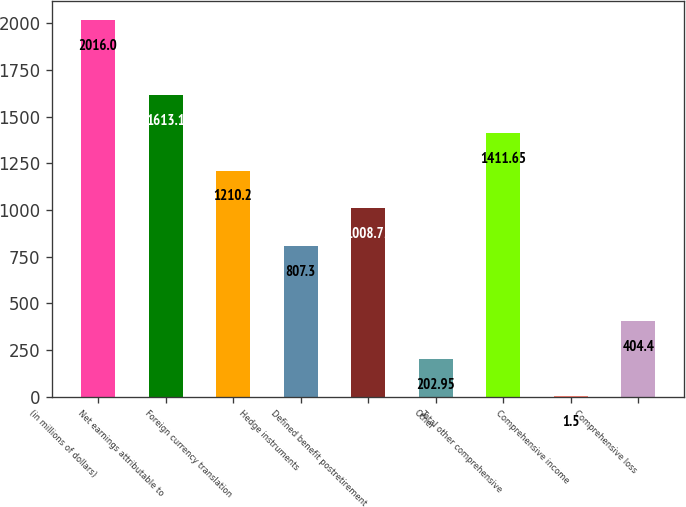Convert chart to OTSL. <chart><loc_0><loc_0><loc_500><loc_500><bar_chart><fcel>(in millions of dollars)<fcel>Net earnings attributable to<fcel>Foreign currency translation<fcel>Hedge instruments<fcel>Defined benefit postretirement<fcel>Other<fcel>Total other comprehensive<fcel>Comprehensive income<fcel>Comprehensive loss<nl><fcel>2016<fcel>1613.1<fcel>1210.2<fcel>807.3<fcel>1008.75<fcel>202.95<fcel>1411.65<fcel>1.5<fcel>404.4<nl></chart> 